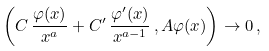<formula> <loc_0><loc_0><loc_500><loc_500>\left ( C \, \frac { \varphi ( x ) } { x ^ { a } } + C ^ { \prime } \, \frac { \varphi ^ { \prime } ( x ) } { x ^ { a - 1 } } \, , A \varphi ( x ) \right ) \rightarrow 0 \, ,</formula> 